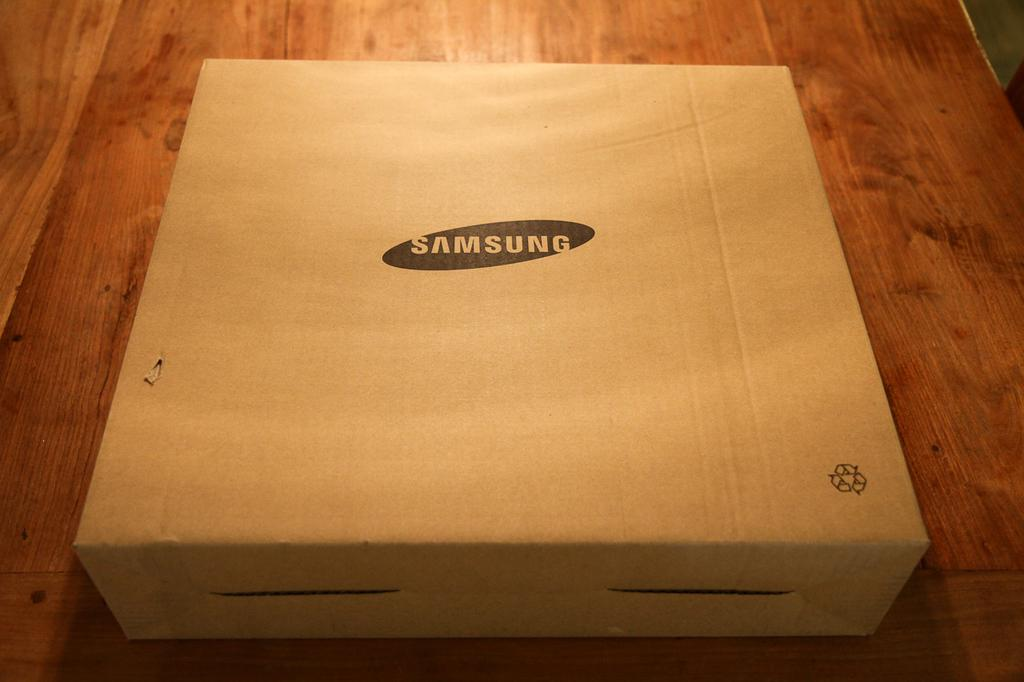<image>
Write a terse but informative summary of the picture. a white box with a black oval on it and the word samsung in the oval 